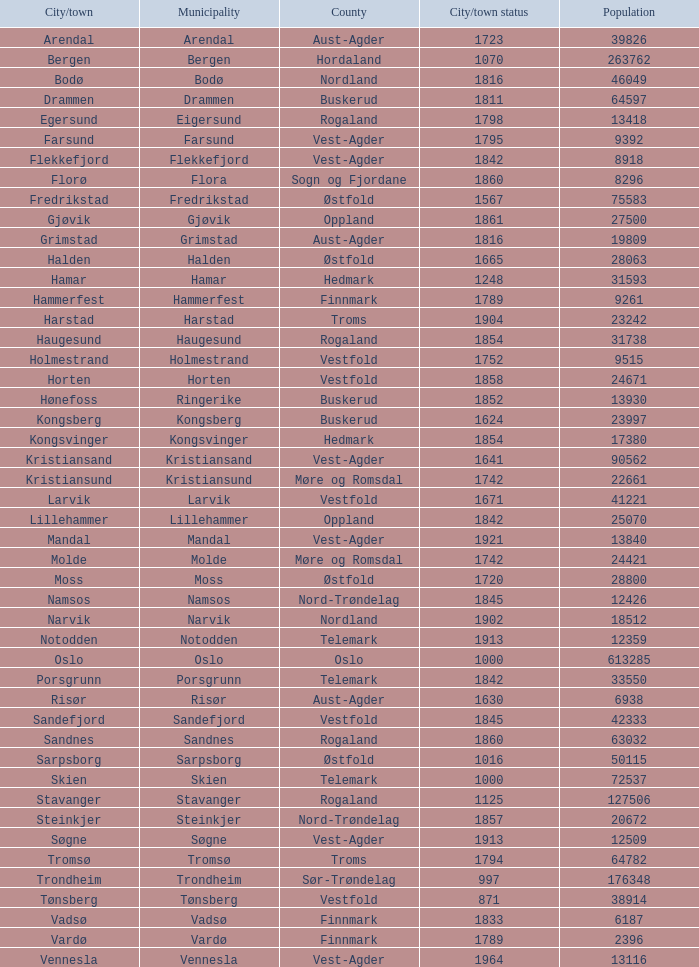What is the total population in the city/town of Arendal? 1.0. Parse the table in full. {'header': ['City/town', 'Municipality', 'County', 'City/town status', 'Population'], 'rows': [['Arendal', 'Arendal', 'Aust-Agder', '1723', '39826'], ['Bergen', 'Bergen', 'Hordaland', '1070', '263762'], ['Bodø', 'Bodø', 'Nordland', '1816', '46049'], ['Drammen', 'Drammen', 'Buskerud', '1811', '64597'], ['Egersund', 'Eigersund', 'Rogaland', '1798', '13418'], ['Farsund', 'Farsund', 'Vest-Agder', '1795', '9392'], ['Flekkefjord', 'Flekkefjord', 'Vest-Agder', '1842', '8918'], ['Florø', 'Flora', 'Sogn og Fjordane', '1860', '8296'], ['Fredrikstad', 'Fredrikstad', 'Østfold', '1567', '75583'], ['Gjøvik', 'Gjøvik', 'Oppland', '1861', '27500'], ['Grimstad', 'Grimstad', 'Aust-Agder', '1816', '19809'], ['Halden', 'Halden', 'Østfold', '1665', '28063'], ['Hamar', 'Hamar', 'Hedmark', '1248', '31593'], ['Hammerfest', 'Hammerfest', 'Finnmark', '1789', '9261'], ['Harstad', 'Harstad', 'Troms', '1904', '23242'], ['Haugesund', 'Haugesund', 'Rogaland', '1854', '31738'], ['Holmestrand', 'Holmestrand', 'Vestfold', '1752', '9515'], ['Horten', 'Horten', 'Vestfold', '1858', '24671'], ['Hønefoss', 'Ringerike', 'Buskerud', '1852', '13930'], ['Kongsberg', 'Kongsberg', 'Buskerud', '1624', '23997'], ['Kongsvinger', 'Kongsvinger', 'Hedmark', '1854', '17380'], ['Kristiansand', 'Kristiansand', 'Vest-Agder', '1641', '90562'], ['Kristiansund', 'Kristiansund', 'Møre og Romsdal', '1742', '22661'], ['Larvik', 'Larvik', 'Vestfold', '1671', '41221'], ['Lillehammer', 'Lillehammer', 'Oppland', '1842', '25070'], ['Mandal', 'Mandal', 'Vest-Agder', '1921', '13840'], ['Molde', 'Molde', 'Møre og Romsdal', '1742', '24421'], ['Moss', 'Moss', 'Østfold', '1720', '28800'], ['Namsos', 'Namsos', 'Nord-Trøndelag', '1845', '12426'], ['Narvik', 'Narvik', 'Nordland', '1902', '18512'], ['Notodden', 'Notodden', 'Telemark', '1913', '12359'], ['Oslo', 'Oslo', 'Oslo', '1000', '613285'], ['Porsgrunn', 'Porsgrunn', 'Telemark', '1842', '33550'], ['Risør', 'Risør', 'Aust-Agder', '1630', '6938'], ['Sandefjord', 'Sandefjord', 'Vestfold', '1845', '42333'], ['Sandnes', 'Sandnes', 'Rogaland', '1860', '63032'], ['Sarpsborg', 'Sarpsborg', 'Østfold', '1016', '50115'], ['Skien', 'Skien', 'Telemark', '1000', '72537'], ['Stavanger', 'Stavanger', 'Rogaland', '1125', '127506'], ['Steinkjer', 'Steinkjer', 'Nord-Trøndelag', '1857', '20672'], ['Søgne', 'Søgne', 'Vest-Agder', '1913', '12509'], ['Tromsø', 'Tromsø', 'Troms', '1794', '64782'], ['Trondheim', 'Trondheim', 'Sør-Trøndelag', '997', '176348'], ['Tønsberg', 'Tønsberg', 'Vestfold', '871', '38914'], ['Vadsø', 'Vadsø', 'Finnmark', '1833', '6187'], ['Vardø', 'Vardø', 'Finnmark', '1789', '2396'], ['Vennesla', 'Vennesla', 'Vest-Agder', '1964', '13116']]} 